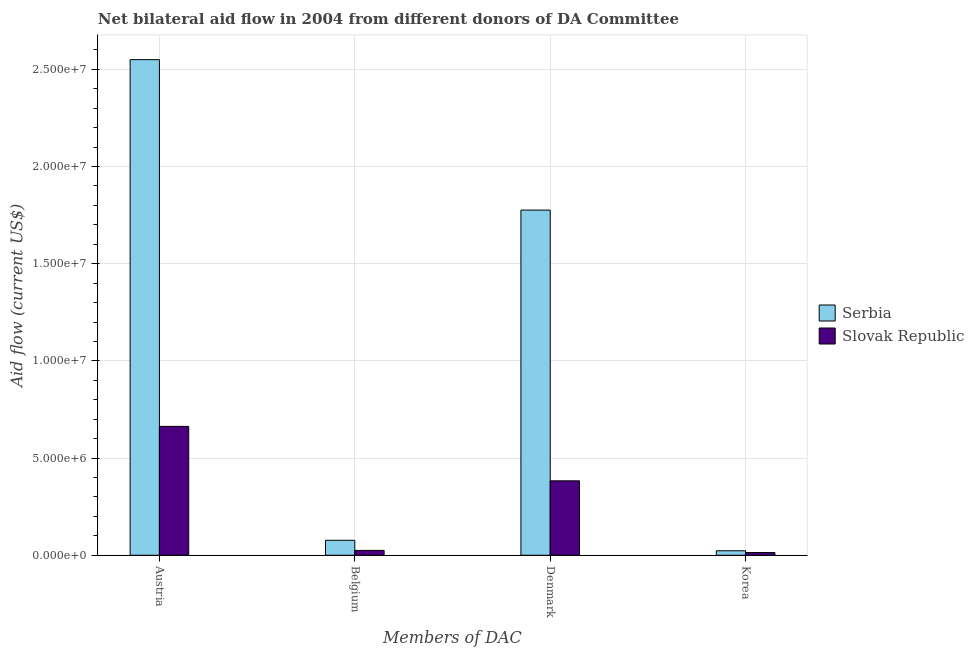How many different coloured bars are there?
Make the answer very short. 2. How many groups of bars are there?
Provide a short and direct response. 4. Are the number of bars per tick equal to the number of legend labels?
Your answer should be very brief. Yes. How many bars are there on the 4th tick from the right?
Your response must be concise. 2. What is the amount of aid given by austria in Serbia?
Your response must be concise. 2.55e+07. Across all countries, what is the maximum amount of aid given by belgium?
Provide a succinct answer. 7.70e+05. Across all countries, what is the minimum amount of aid given by denmark?
Give a very brief answer. 3.83e+06. In which country was the amount of aid given by belgium maximum?
Offer a terse response. Serbia. In which country was the amount of aid given by korea minimum?
Your answer should be compact. Slovak Republic. What is the total amount of aid given by belgium in the graph?
Offer a terse response. 1.02e+06. What is the difference between the amount of aid given by belgium in Serbia and that in Slovak Republic?
Your answer should be compact. 5.20e+05. What is the difference between the amount of aid given by korea in Slovak Republic and the amount of aid given by denmark in Serbia?
Make the answer very short. -1.76e+07. What is the average amount of aid given by belgium per country?
Ensure brevity in your answer.  5.10e+05. What is the difference between the amount of aid given by denmark and amount of aid given by belgium in Serbia?
Give a very brief answer. 1.70e+07. What is the ratio of the amount of aid given by austria in Slovak Republic to that in Serbia?
Your answer should be compact. 0.26. Is the amount of aid given by austria in Slovak Republic less than that in Serbia?
Your response must be concise. Yes. Is the difference between the amount of aid given by austria in Slovak Republic and Serbia greater than the difference between the amount of aid given by belgium in Slovak Republic and Serbia?
Offer a very short reply. No. What is the difference between the highest and the second highest amount of aid given by denmark?
Offer a very short reply. 1.39e+07. What is the difference between the highest and the lowest amount of aid given by korea?
Give a very brief answer. 9.00e+04. In how many countries, is the amount of aid given by korea greater than the average amount of aid given by korea taken over all countries?
Your answer should be compact. 1. Is it the case that in every country, the sum of the amount of aid given by korea and amount of aid given by denmark is greater than the sum of amount of aid given by belgium and amount of aid given by austria?
Provide a succinct answer. Yes. What does the 1st bar from the left in Denmark represents?
Your answer should be very brief. Serbia. What does the 2nd bar from the right in Belgium represents?
Offer a terse response. Serbia. How many bars are there?
Offer a terse response. 8. Are the values on the major ticks of Y-axis written in scientific E-notation?
Offer a very short reply. Yes. Does the graph contain any zero values?
Your response must be concise. No. Where does the legend appear in the graph?
Your answer should be compact. Center right. How many legend labels are there?
Ensure brevity in your answer.  2. What is the title of the graph?
Keep it short and to the point. Net bilateral aid flow in 2004 from different donors of DA Committee. Does "Kuwait" appear as one of the legend labels in the graph?
Make the answer very short. No. What is the label or title of the X-axis?
Ensure brevity in your answer.  Members of DAC. What is the Aid flow (current US$) in Serbia in Austria?
Keep it short and to the point. 2.55e+07. What is the Aid flow (current US$) of Slovak Republic in Austria?
Provide a succinct answer. 6.63e+06. What is the Aid flow (current US$) in Serbia in Belgium?
Your answer should be very brief. 7.70e+05. What is the Aid flow (current US$) of Slovak Republic in Belgium?
Make the answer very short. 2.50e+05. What is the Aid flow (current US$) in Serbia in Denmark?
Offer a terse response. 1.78e+07. What is the Aid flow (current US$) of Slovak Republic in Denmark?
Give a very brief answer. 3.83e+06. What is the Aid flow (current US$) of Serbia in Korea?
Offer a very short reply. 2.30e+05. What is the Aid flow (current US$) in Slovak Republic in Korea?
Your answer should be compact. 1.40e+05. Across all Members of DAC, what is the maximum Aid flow (current US$) of Serbia?
Your answer should be very brief. 2.55e+07. Across all Members of DAC, what is the maximum Aid flow (current US$) of Slovak Republic?
Your answer should be very brief. 6.63e+06. Across all Members of DAC, what is the minimum Aid flow (current US$) in Slovak Republic?
Ensure brevity in your answer.  1.40e+05. What is the total Aid flow (current US$) of Serbia in the graph?
Offer a terse response. 4.43e+07. What is the total Aid flow (current US$) of Slovak Republic in the graph?
Give a very brief answer. 1.08e+07. What is the difference between the Aid flow (current US$) of Serbia in Austria and that in Belgium?
Offer a very short reply. 2.47e+07. What is the difference between the Aid flow (current US$) of Slovak Republic in Austria and that in Belgium?
Your answer should be very brief. 6.38e+06. What is the difference between the Aid flow (current US$) in Serbia in Austria and that in Denmark?
Your response must be concise. 7.74e+06. What is the difference between the Aid flow (current US$) in Slovak Republic in Austria and that in Denmark?
Ensure brevity in your answer.  2.80e+06. What is the difference between the Aid flow (current US$) in Serbia in Austria and that in Korea?
Provide a short and direct response. 2.53e+07. What is the difference between the Aid flow (current US$) in Slovak Republic in Austria and that in Korea?
Keep it short and to the point. 6.49e+06. What is the difference between the Aid flow (current US$) of Serbia in Belgium and that in Denmark?
Your response must be concise. -1.70e+07. What is the difference between the Aid flow (current US$) of Slovak Republic in Belgium and that in Denmark?
Provide a short and direct response. -3.58e+06. What is the difference between the Aid flow (current US$) in Serbia in Belgium and that in Korea?
Provide a short and direct response. 5.40e+05. What is the difference between the Aid flow (current US$) in Serbia in Denmark and that in Korea?
Give a very brief answer. 1.75e+07. What is the difference between the Aid flow (current US$) in Slovak Republic in Denmark and that in Korea?
Offer a very short reply. 3.69e+06. What is the difference between the Aid flow (current US$) in Serbia in Austria and the Aid flow (current US$) in Slovak Republic in Belgium?
Offer a very short reply. 2.52e+07. What is the difference between the Aid flow (current US$) in Serbia in Austria and the Aid flow (current US$) in Slovak Republic in Denmark?
Provide a succinct answer. 2.17e+07. What is the difference between the Aid flow (current US$) of Serbia in Austria and the Aid flow (current US$) of Slovak Republic in Korea?
Ensure brevity in your answer.  2.54e+07. What is the difference between the Aid flow (current US$) in Serbia in Belgium and the Aid flow (current US$) in Slovak Republic in Denmark?
Offer a very short reply. -3.06e+06. What is the difference between the Aid flow (current US$) in Serbia in Belgium and the Aid flow (current US$) in Slovak Republic in Korea?
Offer a very short reply. 6.30e+05. What is the difference between the Aid flow (current US$) in Serbia in Denmark and the Aid flow (current US$) in Slovak Republic in Korea?
Offer a very short reply. 1.76e+07. What is the average Aid flow (current US$) in Serbia per Members of DAC?
Make the answer very short. 1.11e+07. What is the average Aid flow (current US$) in Slovak Republic per Members of DAC?
Provide a short and direct response. 2.71e+06. What is the difference between the Aid flow (current US$) in Serbia and Aid flow (current US$) in Slovak Republic in Austria?
Offer a terse response. 1.89e+07. What is the difference between the Aid flow (current US$) of Serbia and Aid flow (current US$) of Slovak Republic in Belgium?
Provide a short and direct response. 5.20e+05. What is the difference between the Aid flow (current US$) in Serbia and Aid flow (current US$) in Slovak Republic in Denmark?
Provide a short and direct response. 1.39e+07. What is the ratio of the Aid flow (current US$) of Serbia in Austria to that in Belgium?
Provide a short and direct response. 33.12. What is the ratio of the Aid flow (current US$) of Slovak Republic in Austria to that in Belgium?
Provide a succinct answer. 26.52. What is the ratio of the Aid flow (current US$) in Serbia in Austria to that in Denmark?
Give a very brief answer. 1.44. What is the ratio of the Aid flow (current US$) in Slovak Republic in Austria to that in Denmark?
Make the answer very short. 1.73. What is the ratio of the Aid flow (current US$) in Serbia in Austria to that in Korea?
Ensure brevity in your answer.  110.87. What is the ratio of the Aid flow (current US$) of Slovak Republic in Austria to that in Korea?
Give a very brief answer. 47.36. What is the ratio of the Aid flow (current US$) of Serbia in Belgium to that in Denmark?
Give a very brief answer. 0.04. What is the ratio of the Aid flow (current US$) in Slovak Republic in Belgium to that in Denmark?
Your answer should be very brief. 0.07. What is the ratio of the Aid flow (current US$) of Serbia in Belgium to that in Korea?
Provide a succinct answer. 3.35. What is the ratio of the Aid flow (current US$) in Slovak Republic in Belgium to that in Korea?
Offer a terse response. 1.79. What is the ratio of the Aid flow (current US$) of Serbia in Denmark to that in Korea?
Your response must be concise. 77.22. What is the ratio of the Aid flow (current US$) in Slovak Republic in Denmark to that in Korea?
Offer a terse response. 27.36. What is the difference between the highest and the second highest Aid flow (current US$) of Serbia?
Your response must be concise. 7.74e+06. What is the difference between the highest and the second highest Aid flow (current US$) of Slovak Republic?
Your response must be concise. 2.80e+06. What is the difference between the highest and the lowest Aid flow (current US$) of Serbia?
Your answer should be very brief. 2.53e+07. What is the difference between the highest and the lowest Aid flow (current US$) of Slovak Republic?
Give a very brief answer. 6.49e+06. 